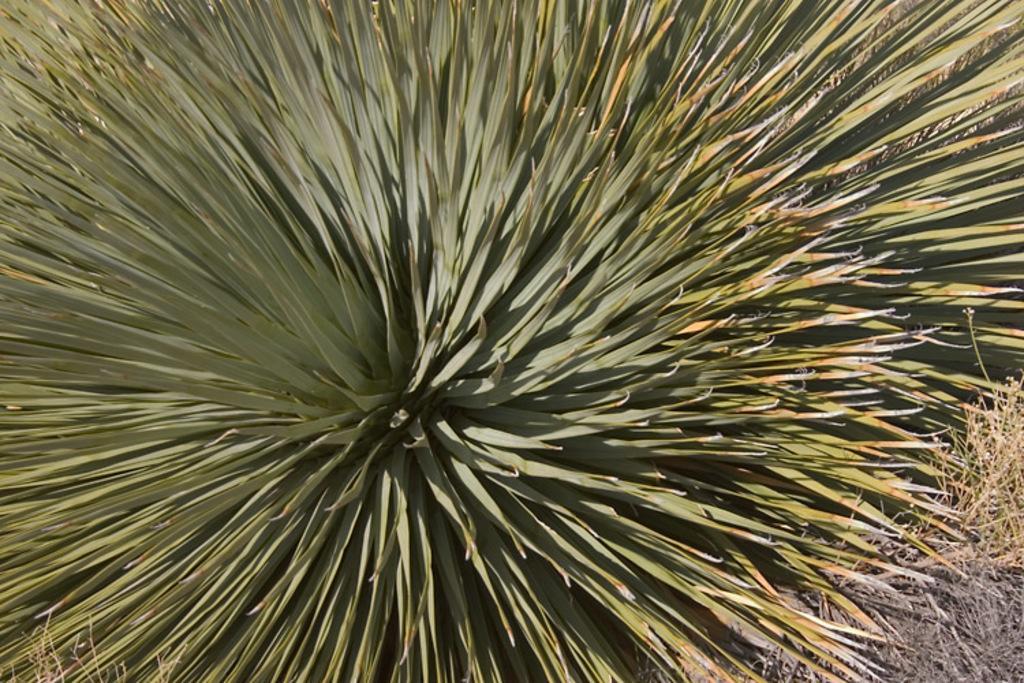In one or two sentences, can you explain what this image depicts? In the center of the image there is plant. 